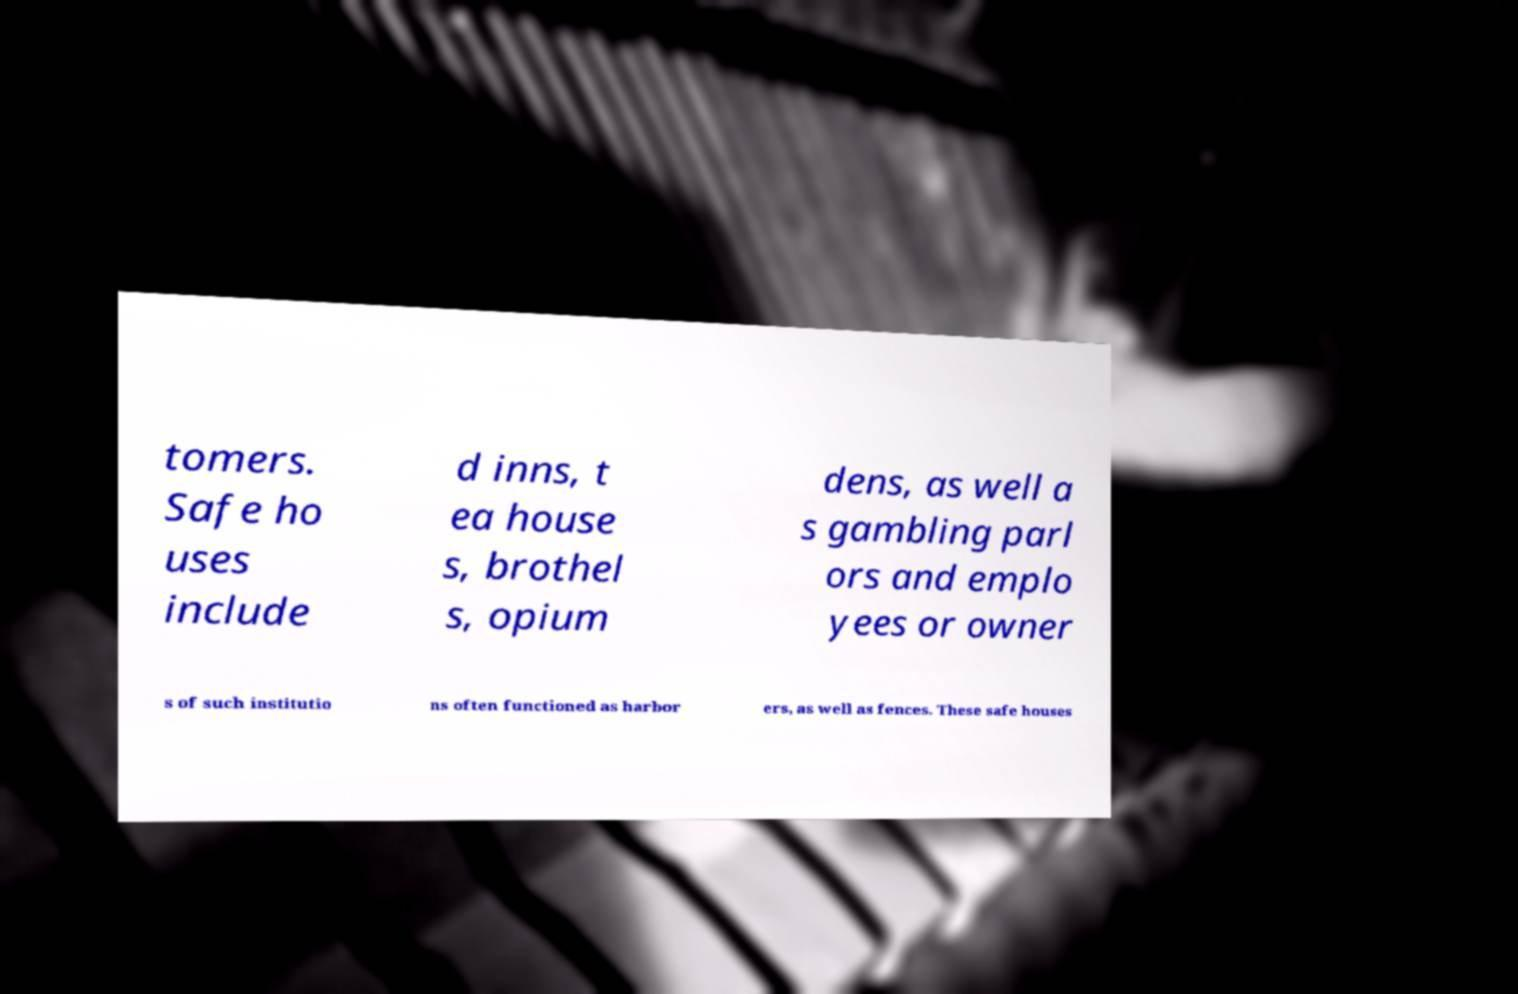Could you assist in decoding the text presented in this image and type it out clearly? tomers. Safe ho uses include d inns, t ea house s, brothel s, opium dens, as well a s gambling parl ors and emplo yees or owner s of such institutio ns often functioned as harbor ers, as well as fences. These safe houses 